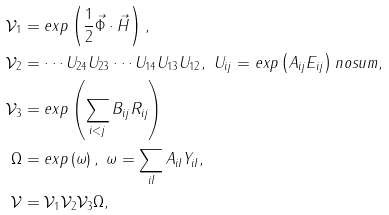<formula> <loc_0><loc_0><loc_500><loc_500>\mathcal { V } _ { 1 } & = e x p \left ( \frac { 1 } { 2 } \vec { \Phi } \cdot \vec { H } \right ) , \\ \mathcal { V } _ { 2 } & = \cdots U _ { 2 4 } U _ { 2 3 } \cdots U _ { 1 4 } U _ { 1 3 } U _ { 1 2 } , \ U _ { i j } = e x p \left ( A _ { i j } E _ { i j } \right ) n o s u m , \\ \mathcal { V } _ { 3 } & = e x p \left ( \sum _ { i < j } B _ { i j } R _ { i j } \right ) \\ \Omega & = e x p \left ( \omega \right ) , \ \omega = \sum _ { i I } A _ { i I } Y _ { i I } , \\ \mathcal { V } & = \mathcal { V } _ { 1 } \mathcal { V } _ { 2 } \mathcal { V } _ { 3 } \Omega ,</formula> 